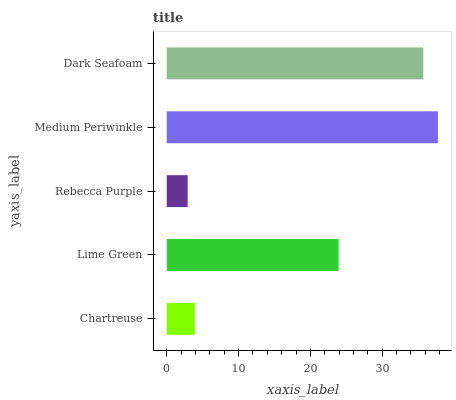Is Rebecca Purple the minimum?
Answer yes or no. Yes. Is Medium Periwinkle the maximum?
Answer yes or no. Yes. Is Lime Green the minimum?
Answer yes or no. No. Is Lime Green the maximum?
Answer yes or no. No. Is Lime Green greater than Chartreuse?
Answer yes or no. Yes. Is Chartreuse less than Lime Green?
Answer yes or no. Yes. Is Chartreuse greater than Lime Green?
Answer yes or no. No. Is Lime Green less than Chartreuse?
Answer yes or no. No. Is Lime Green the high median?
Answer yes or no. Yes. Is Lime Green the low median?
Answer yes or no. Yes. Is Rebecca Purple the high median?
Answer yes or no. No. Is Rebecca Purple the low median?
Answer yes or no. No. 